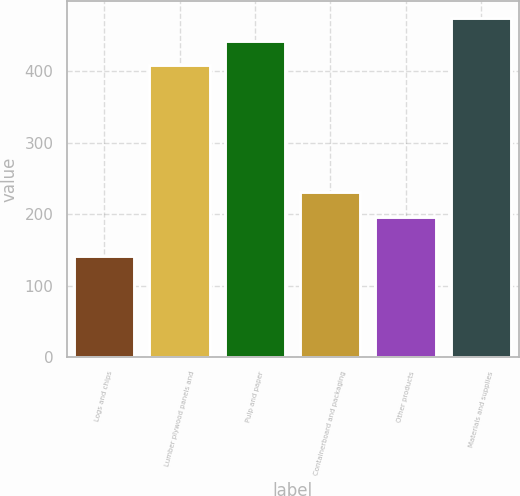Convert chart to OTSL. <chart><loc_0><loc_0><loc_500><loc_500><bar_chart><fcel>Logs and chips<fcel>Lumber plywood panels and<fcel>Pulp and paper<fcel>Containerboard and packaging<fcel>Other products<fcel>Materials and supplies<nl><fcel>142<fcel>409<fcel>441.9<fcel>232<fcel>196<fcel>474.8<nl></chart> 